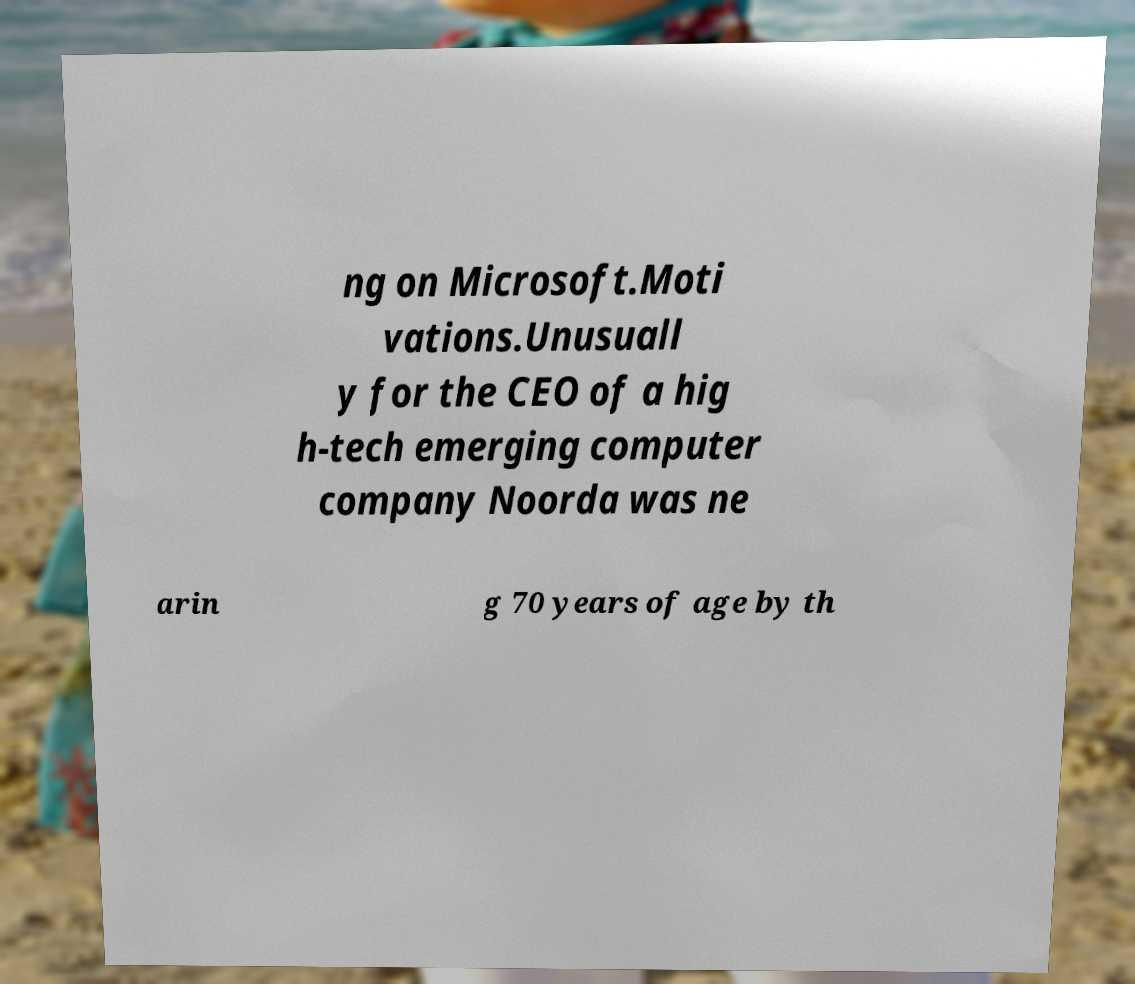What messages or text are displayed in this image? I need them in a readable, typed format. ng on Microsoft.Moti vations.Unusuall y for the CEO of a hig h-tech emerging computer company Noorda was ne arin g 70 years of age by th 